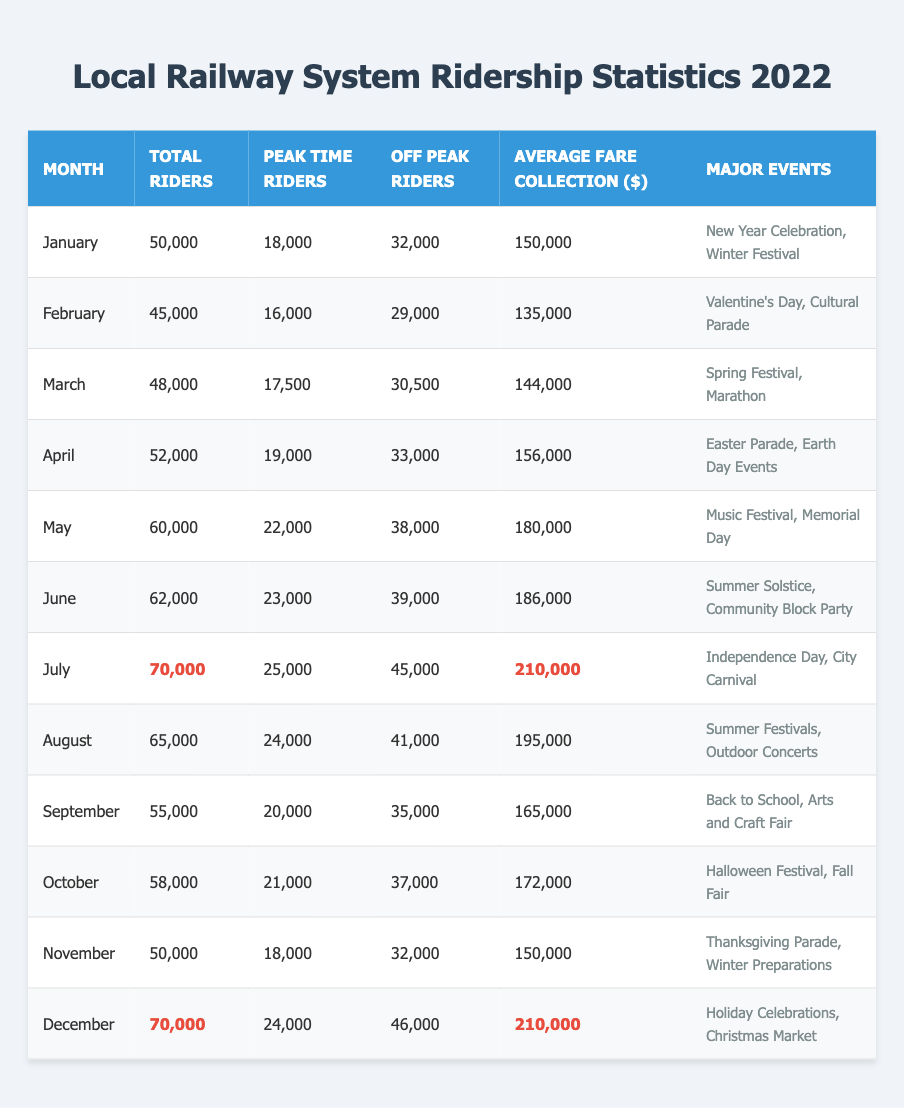What was the total ridership in July? The table indicates that the total number of riders in July is listed directly. By looking at the July row, we find the value is 70,000.
Answer: 70,000 How many peak time riders were there in December? December's row shows that the number of peak time riders is directly indicated in the table, which is 24,000.
Answer: 24,000 Which month had the highest average fare collection? Scanning through the average fare collection values in the table, both July and December have the highest value of 210,000. Therefore, both months are tied for the highest.
Answer: July and December Was there a month when the number of off-peak riders exceeded 40,000? By comparing the off-peak rider numbers across each month, we can see that the months of July, August, and December all had values above 40,000.
Answer: Yes What is the total number of riders from January to March? To find the total, we sum the total riders for January (50,000), February (45,000), and March (48,000): 50,000 + 45,000 + 48,000 = 143,000.
Answer: 143,000 Which month had the least total ridership? Looking at the total riders column in the table, we see February had the least total ridership with a number of 45,000.
Answer: February What was the average number of total riders across the entire year? To determine the average, we need to sum the total number of riders for all months (50,000 + 45,000 + 48,000 + 52,000 + 60,000 + 62,000 + 70,000 + 65,000 + 55,000 + 58,000 + 50,000 + 70,000 =  683,000) and then divide by the number of months (12). The calculation gives us an average of 56,916.67.
Answer: 56,917 How many months had total ridership below 55,000? By reviewing the total riders for each month, we find that January (50,000), February (45,000), and March (48,000) are the only months below 55,000. This totals to 3 months.
Answer: 3 What was the average fare collection in months where major events included a festival? The months with major events including a festival are January (150,000), March (144,000), May (180,000), June (186,000), July (210,000), August (195,000), October (172,000), December (210,000). Summing these values (1,344,000) and dividing by the 8 months gives an average fare collection of 168,000.
Answer: 168,000 How much higher was the peak time ridership in July compared to January? The peak time ridership in July is 25,000 while in January it is 18,000. To find the difference, we subtract January's value from July's: 25,000 - 18,000 = 7,000, indicating July's peak is 7,000 higher.
Answer: 7,000 Did the total number of riders in November equal that in February? By checking the table, November has 50,000 riders and February has 45,000, which means they are not equal.
Answer: No 